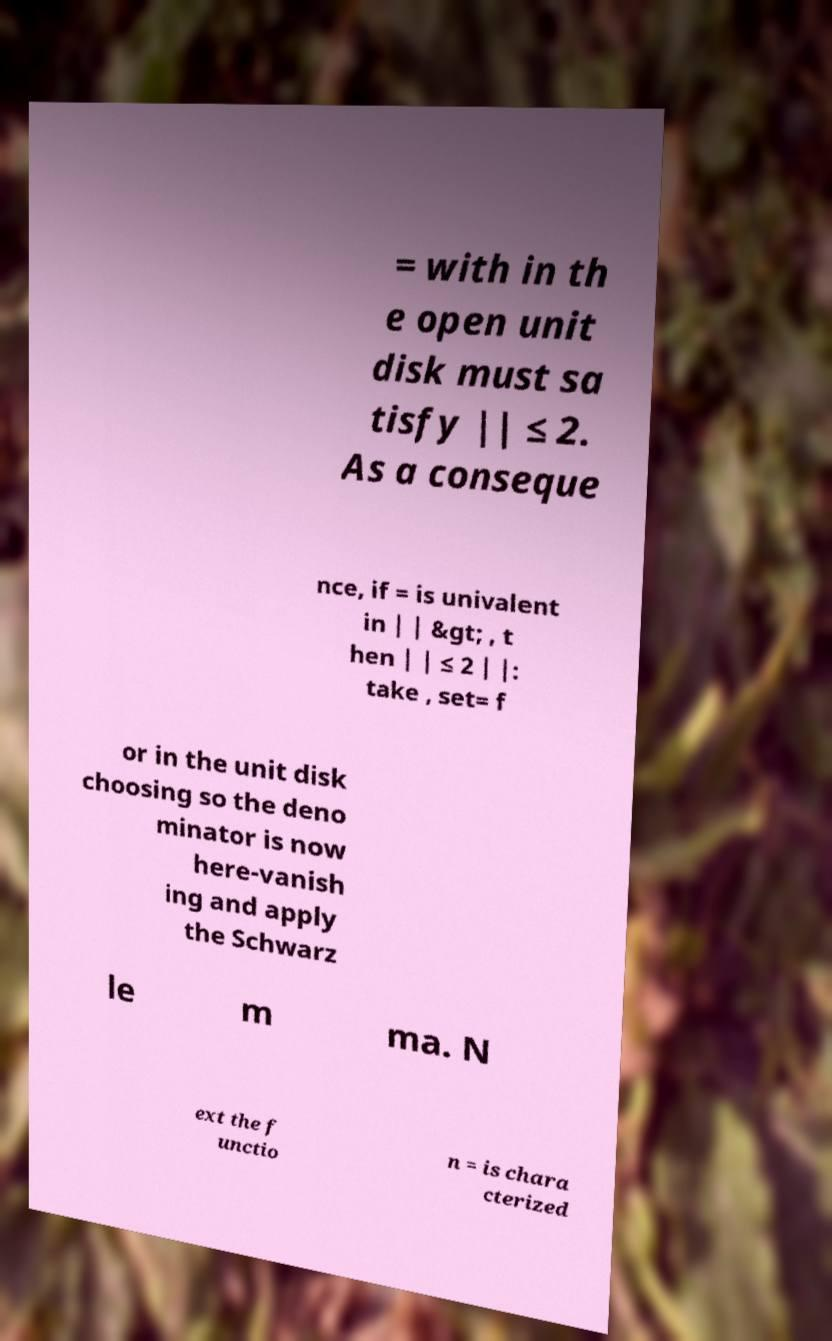Can you read and provide the text displayed in the image?This photo seems to have some interesting text. Can you extract and type it out for me? = with in th e open unit disk must sa tisfy || ≤ 2. As a conseque nce, if = is univalent in | | &gt; , t hen | | ≤ 2 | |: take , set= f or in the unit disk choosing so the deno minator is now here-vanish ing and apply the Schwarz le m ma. N ext the f unctio n = is chara cterized 